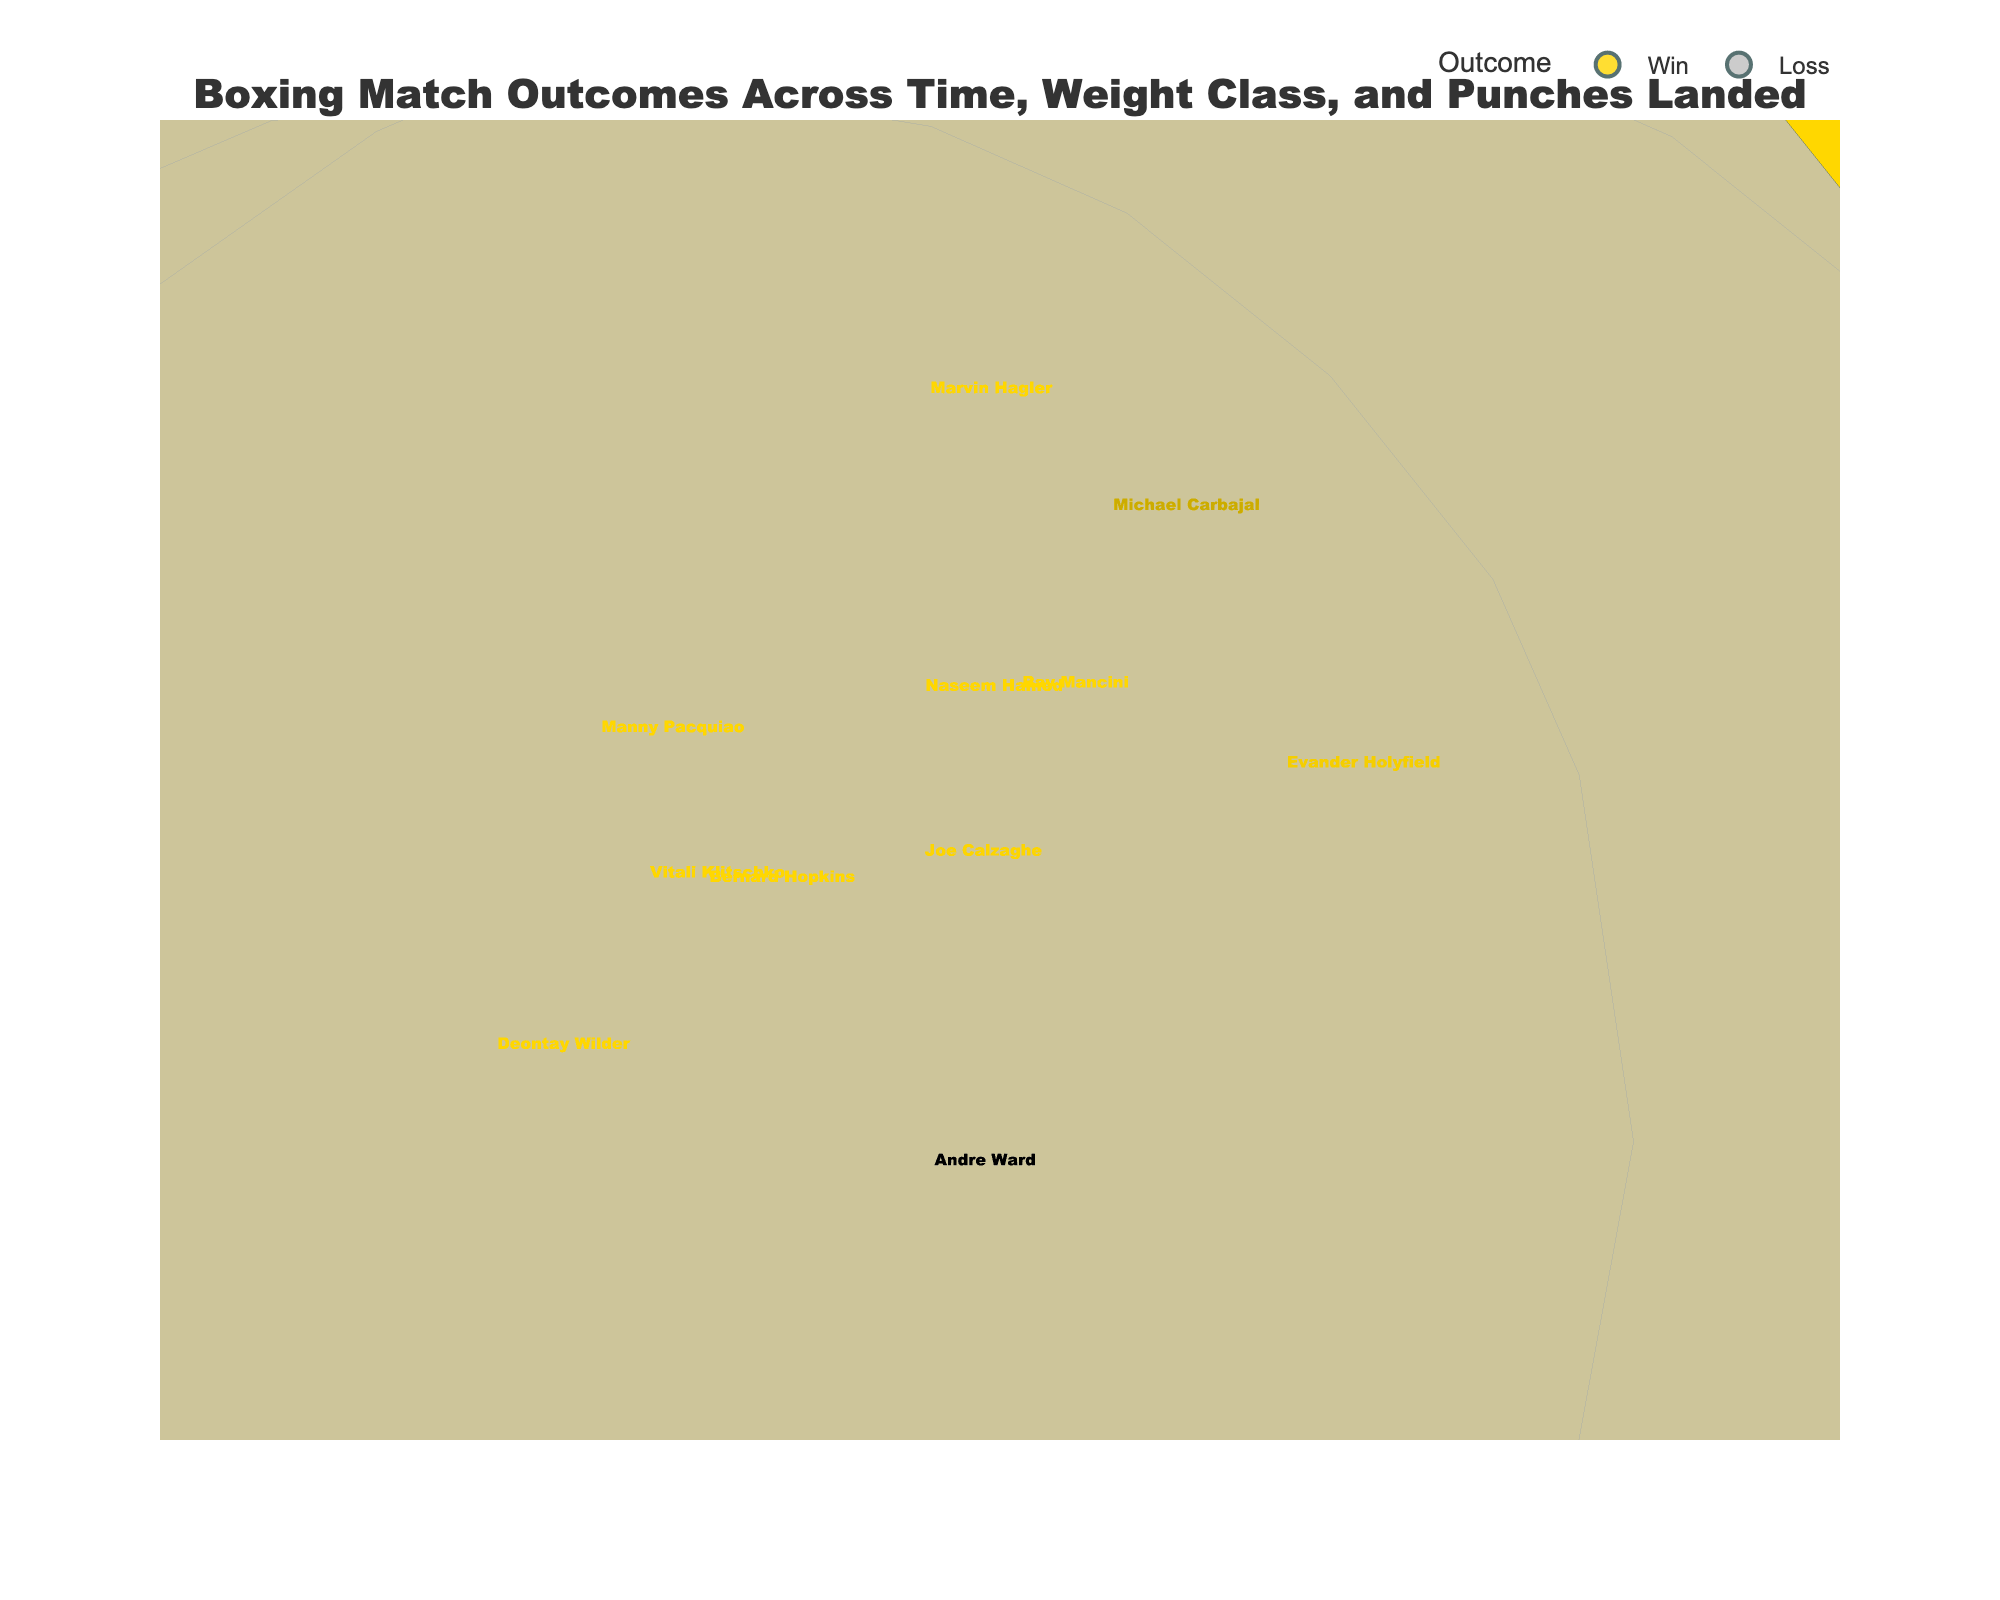What's the title of the figure? The title is normally found at the top center of the figure. Here, it is clearly written and easy to identify.
Answer: Boxing Match Outcomes Across Time, Weight Class, and Punches Landed Which weight class had the highest total punches landed in a match? Look for the bubble that is highest on the z-axis (Total Punches Landed) and identify its y-axis value (Weight Class).
Answer: Middleweight How many matches represented in the figure were losses? Count the number of bubbles that are colored differently, typically less vibrant as indicated by the legend for Losses.
Answer: 1 Which boxer landed the fewest punches in a win, and how many punches were they? Find the smallest bubble associated with a win and hover to see the boxer's name and the corresponding Total Punches Landed value.
Answer: Deontay Wilder, 176 Are there more matches from the 20th century or the 21st century? Count the bubbles on the x-axis from 1900-1999 versus 2000-2021.
Answer: More from the 20th century Which weight class does not have any match outcome recorded in the 20th century? Identify which weight class bubbles do not align with years 1900-1999 on the x-axis.
Answer: Super Middleweight In which decade did the featherweight boxer win recorded? Locate the Featherweight bubble and note its position on the x-axis in terms of decades.
Answer: 1990s Compare the number of punches landed by Heavyweight boxers from the 1970s versus the 2000s. Identify the Heavyweight bubbles in the specified decades and compare their z-axis values (Total Punches Landed).
Answer: 335 vs. 225 (1974: 335 by Muhammad Ali, 2002: 225 by Vitali Klitschko) Which match had the most punches landed by a boxer who lost, and in what year did it occur? Identify the largest bubble colored for a loss and note the corresponding year.
Answer: Vitali Klitschko, 2002 What is the average number of punches landed in winning matches for Heavyweight boxers? Sum up the total punches landed by Heavyweight winners and divide by the number of Heavyweight winning bubbles. (335 + 288 + 265 + 176) / 4.
Answer: 266 